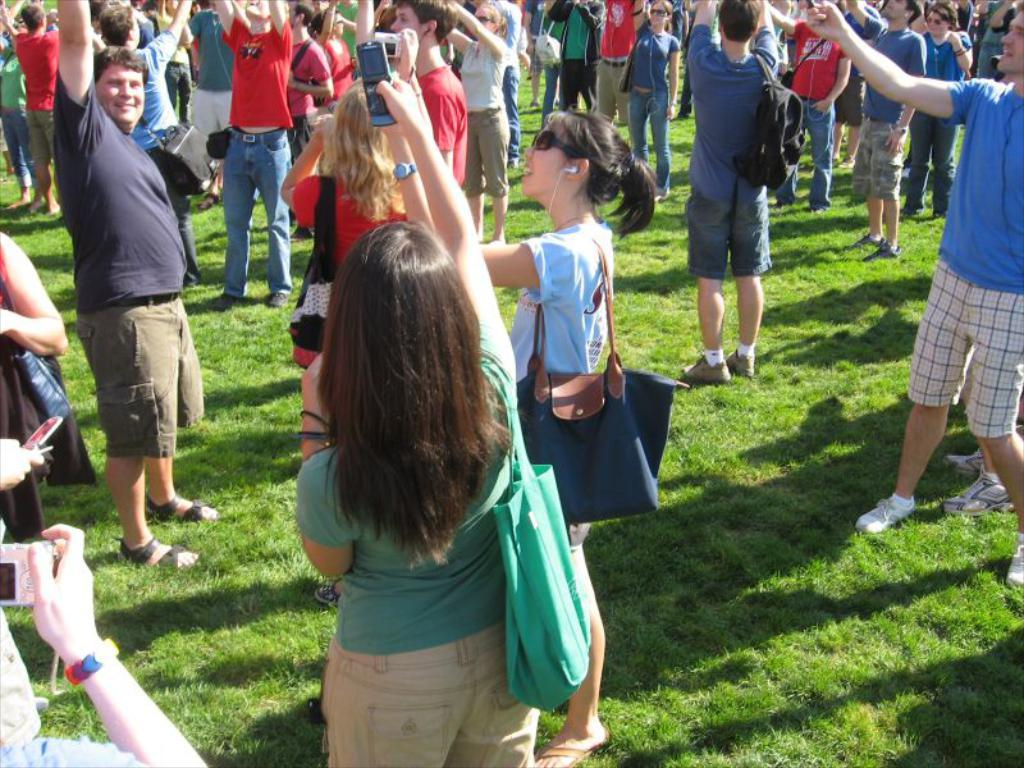What is the main subject of the image? The main subject of the image is people. Where are the people located in the image? The people are in the center of the image. What type of ground is visible at the bottom of the image? There is grass at the bottom of the image. What type of nerve can be seen in the image? There is no nerve present in the image. Can you see a nest in the image? There is no nest present in the image. 